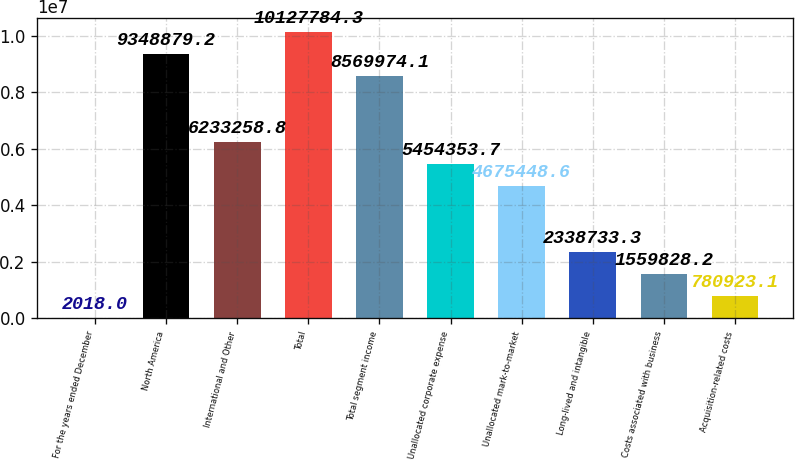Convert chart. <chart><loc_0><loc_0><loc_500><loc_500><bar_chart><fcel>For the years ended December<fcel>North America<fcel>International and Other<fcel>Total<fcel>Total segment income<fcel>Unallocated corporate expense<fcel>Unallocated mark-to-market<fcel>Long-lived and intangible<fcel>Costs associated with business<fcel>Acquisition-related costs<nl><fcel>2018<fcel>9.34888e+06<fcel>6.23326e+06<fcel>1.01278e+07<fcel>8.56997e+06<fcel>5.45435e+06<fcel>4.67545e+06<fcel>2.33873e+06<fcel>1.55983e+06<fcel>780923<nl></chart> 